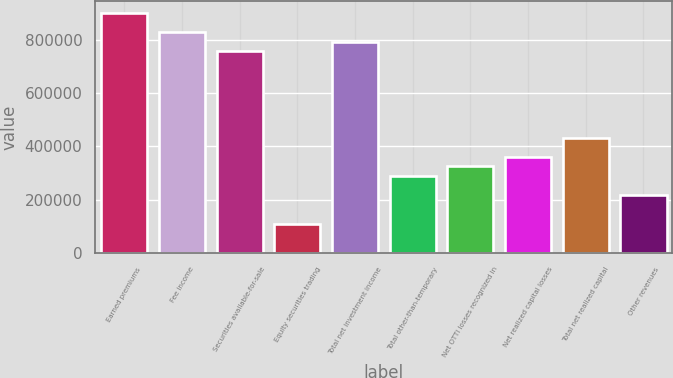Convert chart to OTSL. <chart><loc_0><loc_0><loc_500><loc_500><bar_chart><fcel>Earned premiums<fcel>Fee income<fcel>Securities available-for-sale<fcel>Equity securities trading<fcel>Total net investment income<fcel>Total other-than-temporary<fcel>Net OTTI losses recognized in<fcel>Net realized capital losses<fcel>Total net realized capital<fcel>Other revenues<nl><fcel>900900<fcel>828828<fcel>756756<fcel>108110<fcel>792792<fcel>288289<fcel>324325<fcel>360361<fcel>432433<fcel>216217<nl></chart> 